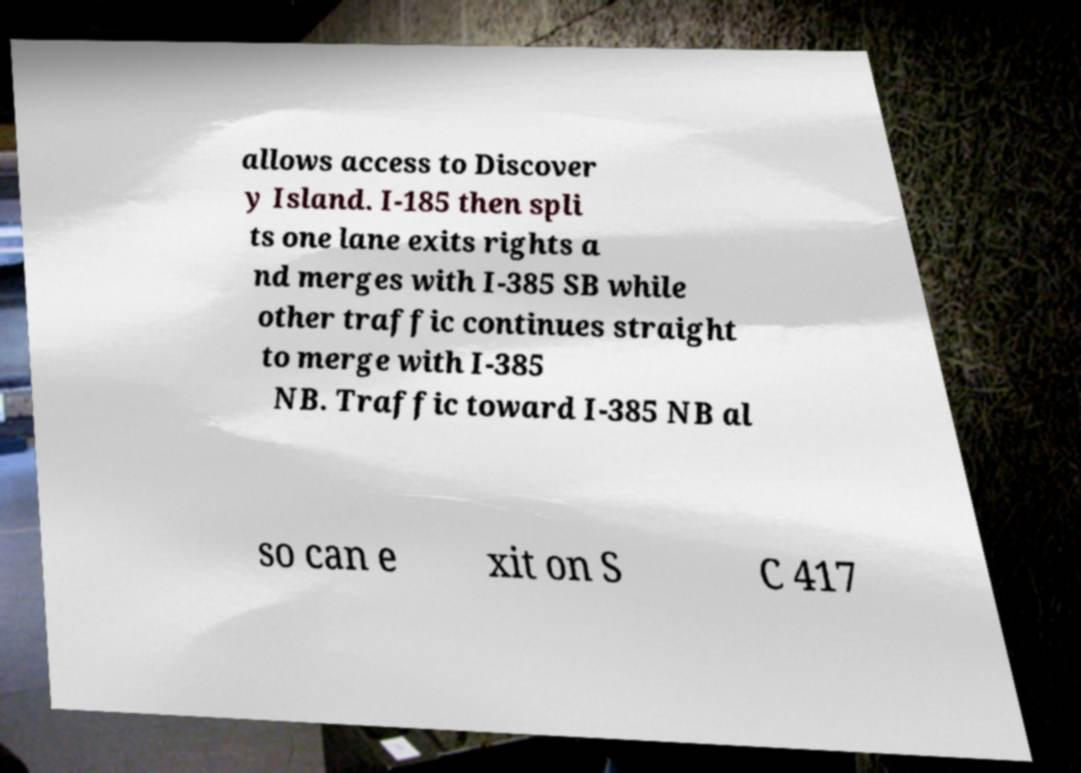For documentation purposes, I need the text within this image transcribed. Could you provide that? allows access to Discover y Island. I-185 then spli ts one lane exits rights a nd merges with I-385 SB while other traffic continues straight to merge with I-385 NB. Traffic toward I-385 NB al so can e xit on S C 417 